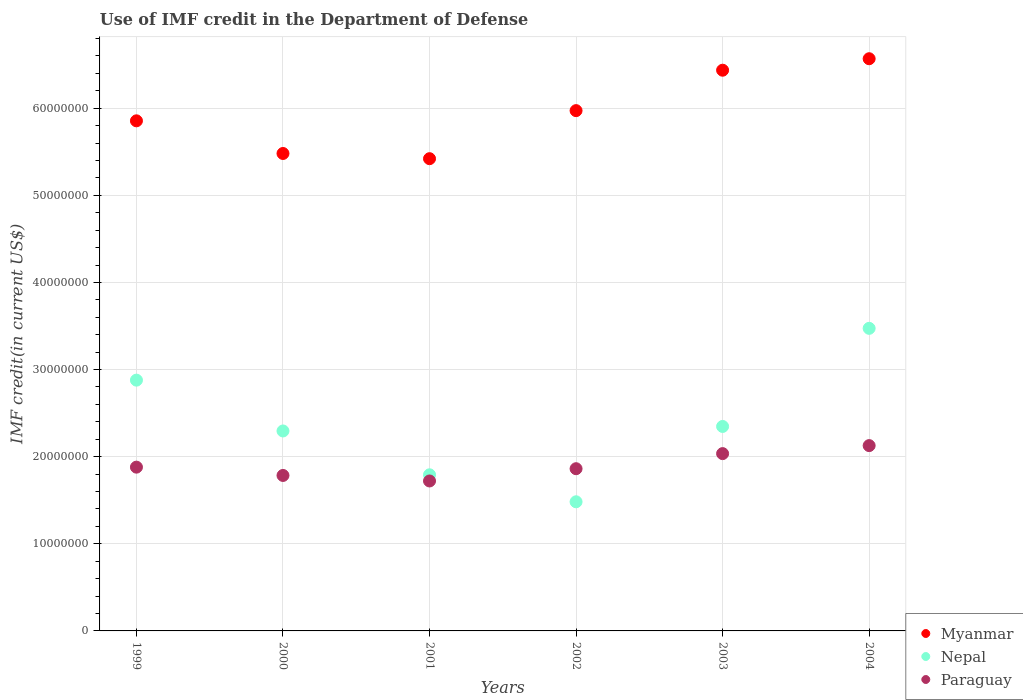How many different coloured dotlines are there?
Your answer should be very brief. 3. What is the IMF credit in the Department of Defense in Paraguay in 2000?
Your answer should be compact. 1.78e+07. Across all years, what is the maximum IMF credit in the Department of Defense in Nepal?
Your answer should be compact. 3.47e+07. Across all years, what is the minimum IMF credit in the Department of Defense in Paraguay?
Your response must be concise. 1.72e+07. In which year was the IMF credit in the Department of Defense in Paraguay maximum?
Provide a succinct answer. 2004. What is the total IMF credit in the Department of Defense in Nepal in the graph?
Your response must be concise. 1.43e+08. What is the difference between the IMF credit in the Department of Defense in Nepal in 2000 and that in 2003?
Your answer should be compact. -5.18e+05. What is the difference between the IMF credit in the Department of Defense in Myanmar in 2002 and the IMF credit in the Department of Defense in Paraguay in 2003?
Give a very brief answer. 3.94e+07. What is the average IMF credit in the Department of Defense in Paraguay per year?
Offer a very short reply. 1.90e+07. In the year 2001, what is the difference between the IMF credit in the Department of Defense in Myanmar and IMF credit in the Department of Defense in Paraguay?
Keep it short and to the point. 3.70e+07. What is the ratio of the IMF credit in the Department of Defense in Paraguay in 1999 to that in 2003?
Your response must be concise. 0.92. Is the IMF credit in the Department of Defense in Nepal in 1999 less than that in 2003?
Make the answer very short. No. What is the difference between the highest and the second highest IMF credit in the Department of Defense in Paraguay?
Provide a succinct answer. 9.19e+05. What is the difference between the highest and the lowest IMF credit in the Department of Defense in Nepal?
Your response must be concise. 1.99e+07. Is the sum of the IMF credit in the Department of Defense in Nepal in 1999 and 2000 greater than the maximum IMF credit in the Department of Defense in Paraguay across all years?
Give a very brief answer. Yes. Does the IMF credit in the Department of Defense in Nepal monotonically increase over the years?
Provide a short and direct response. No. Is the IMF credit in the Department of Defense in Myanmar strictly greater than the IMF credit in the Department of Defense in Nepal over the years?
Your answer should be very brief. Yes. How many years are there in the graph?
Offer a terse response. 6. Are the values on the major ticks of Y-axis written in scientific E-notation?
Your response must be concise. No. Does the graph contain any zero values?
Your answer should be very brief. No. Does the graph contain grids?
Your answer should be compact. Yes. Where does the legend appear in the graph?
Your response must be concise. Bottom right. What is the title of the graph?
Offer a terse response. Use of IMF credit in the Department of Defense. Does "Lithuania" appear as one of the legend labels in the graph?
Give a very brief answer. No. What is the label or title of the X-axis?
Provide a succinct answer. Years. What is the label or title of the Y-axis?
Your answer should be very brief. IMF credit(in current US$). What is the IMF credit(in current US$) in Myanmar in 1999?
Your answer should be compact. 5.86e+07. What is the IMF credit(in current US$) of Nepal in 1999?
Offer a terse response. 2.88e+07. What is the IMF credit(in current US$) of Paraguay in 1999?
Ensure brevity in your answer.  1.88e+07. What is the IMF credit(in current US$) of Myanmar in 2000?
Your response must be concise. 5.48e+07. What is the IMF credit(in current US$) in Nepal in 2000?
Provide a short and direct response. 2.30e+07. What is the IMF credit(in current US$) in Paraguay in 2000?
Offer a very short reply. 1.78e+07. What is the IMF credit(in current US$) in Myanmar in 2001?
Offer a terse response. 5.42e+07. What is the IMF credit(in current US$) in Nepal in 2001?
Your answer should be compact. 1.79e+07. What is the IMF credit(in current US$) of Paraguay in 2001?
Your answer should be very brief. 1.72e+07. What is the IMF credit(in current US$) in Myanmar in 2002?
Offer a terse response. 5.97e+07. What is the IMF credit(in current US$) in Nepal in 2002?
Offer a terse response. 1.48e+07. What is the IMF credit(in current US$) of Paraguay in 2002?
Your answer should be compact. 1.86e+07. What is the IMF credit(in current US$) of Myanmar in 2003?
Make the answer very short. 6.44e+07. What is the IMF credit(in current US$) in Nepal in 2003?
Offer a terse response. 2.35e+07. What is the IMF credit(in current US$) in Paraguay in 2003?
Provide a succinct answer. 2.04e+07. What is the IMF credit(in current US$) in Myanmar in 2004?
Provide a short and direct response. 6.57e+07. What is the IMF credit(in current US$) in Nepal in 2004?
Offer a very short reply. 3.47e+07. What is the IMF credit(in current US$) of Paraguay in 2004?
Your response must be concise. 2.13e+07. Across all years, what is the maximum IMF credit(in current US$) of Myanmar?
Make the answer very short. 6.57e+07. Across all years, what is the maximum IMF credit(in current US$) of Nepal?
Ensure brevity in your answer.  3.47e+07. Across all years, what is the maximum IMF credit(in current US$) of Paraguay?
Your answer should be very brief. 2.13e+07. Across all years, what is the minimum IMF credit(in current US$) of Myanmar?
Offer a very short reply. 5.42e+07. Across all years, what is the minimum IMF credit(in current US$) of Nepal?
Ensure brevity in your answer.  1.48e+07. Across all years, what is the minimum IMF credit(in current US$) in Paraguay?
Offer a terse response. 1.72e+07. What is the total IMF credit(in current US$) of Myanmar in the graph?
Keep it short and to the point. 3.57e+08. What is the total IMF credit(in current US$) of Nepal in the graph?
Your answer should be compact. 1.43e+08. What is the total IMF credit(in current US$) in Paraguay in the graph?
Give a very brief answer. 1.14e+08. What is the difference between the IMF credit(in current US$) in Myanmar in 1999 and that in 2000?
Provide a succinct answer. 3.75e+06. What is the difference between the IMF credit(in current US$) of Nepal in 1999 and that in 2000?
Provide a succinct answer. 5.83e+06. What is the difference between the IMF credit(in current US$) in Paraguay in 1999 and that in 2000?
Your answer should be compact. 9.53e+05. What is the difference between the IMF credit(in current US$) in Myanmar in 1999 and that in 2001?
Offer a terse response. 4.35e+06. What is the difference between the IMF credit(in current US$) in Nepal in 1999 and that in 2001?
Make the answer very short. 1.09e+07. What is the difference between the IMF credit(in current US$) of Paraguay in 1999 and that in 2001?
Offer a very short reply. 1.59e+06. What is the difference between the IMF credit(in current US$) of Myanmar in 1999 and that in 2002?
Ensure brevity in your answer.  -1.17e+06. What is the difference between the IMF credit(in current US$) in Nepal in 1999 and that in 2002?
Make the answer very short. 1.40e+07. What is the difference between the IMF credit(in current US$) in Paraguay in 1999 and that in 2002?
Give a very brief answer. 1.78e+05. What is the difference between the IMF credit(in current US$) of Myanmar in 1999 and that in 2003?
Make the answer very short. -5.81e+06. What is the difference between the IMF credit(in current US$) of Nepal in 1999 and that in 2003?
Your response must be concise. 5.32e+06. What is the difference between the IMF credit(in current US$) in Paraguay in 1999 and that in 2003?
Offer a terse response. -1.55e+06. What is the difference between the IMF credit(in current US$) in Myanmar in 1999 and that in 2004?
Offer a very short reply. -7.13e+06. What is the difference between the IMF credit(in current US$) in Nepal in 1999 and that in 2004?
Make the answer very short. -5.95e+06. What is the difference between the IMF credit(in current US$) of Paraguay in 1999 and that in 2004?
Provide a short and direct response. -2.47e+06. What is the difference between the IMF credit(in current US$) in Myanmar in 2000 and that in 2001?
Provide a succinct answer. 5.97e+05. What is the difference between the IMF credit(in current US$) of Nepal in 2000 and that in 2001?
Give a very brief answer. 5.03e+06. What is the difference between the IMF credit(in current US$) of Paraguay in 2000 and that in 2001?
Ensure brevity in your answer.  6.33e+05. What is the difference between the IMF credit(in current US$) of Myanmar in 2000 and that in 2002?
Offer a terse response. -4.92e+06. What is the difference between the IMF credit(in current US$) in Nepal in 2000 and that in 2002?
Give a very brief answer. 8.13e+06. What is the difference between the IMF credit(in current US$) in Paraguay in 2000 and that in 2002?
Make the answer very short. -7.75e+05. What is the difference between the IMF credit(in current US$) of Myanmar in 2000 and that in 2003?
Ensure brevity in your answer.  -9.56e+06. What is the difference between the IMF credit(in current US$) of Nepal in 2000 and that in 2003?
Offer a very short reply. -5.18e+05. What is the difference between the IMF credit(in current US$) of Paraguay in 2000 and that in 2003?
Make the answer very short. -2.51e+06. What is the difference between the IMF credit(in current US$) of Myanmar in 2000 and that in 2004?
Ensure brevity in your answer.  -1.09e+07. What is the difference between the IMF credit(in current US$) of Nepal in 2000 and that in 2004?
Provide a short and direct response. -1.18e+07. What is the difference between the IMF credit(in current US$) in Paraguay in 2000 and that in 2004?
Your answer should be very brief. -3.43e+06. What is the difference between the IMF credit(in current US$) of Myanmar in 2001 and that in 2002?
Your response must be concise. -5.52e+06. What is the difference between the IMF credit(in current US$) in Nepal in 2001 and that in 2002?
Your answer should be compact. 3.10e+06. What is the difference between the IMF credit(in current US$) in Paraguay in 2001 and that in 2002?
Keep it short and to the point. -1.41e+06. What is the difference between the IMF credit(in current US$) in Myanmar in 2001 and that in 2003?
Your response must be concise. -1.02e+07. What is the difference between the IMF credit(in current US$) in Nepal in 2001 and that in 2003?
Keep it short and to the point. -5.55e+06. What is the difference between the IMF credit(in current US$) in Paraguay in 2001 and that in 2003?
Ensure brevity in your answer.  -3.14e+06. What is the difference between the IMF credit(in current US$) of Myanmar in 2001 and that in 2004?
Make the answer very short. -1.15e+07. What is the difference between the IMF credit(in current US$) of Nepal in 2001 and that in 2004?
Offer a terse response. -1.68e+07. What is the difference between the IMF credit(in current US$) of Paraguay in 2001 and that in 2004?
Offer a very short reply. -4.06e+06. What is the difference between the IMF credit(in current US$) in Myanmar in 2002 and that in 2003?
Make the answer very short. -4.64e+06. What is the difference between the IMF credit(in current US$) in Nepal in 2002 and that in 2003?
Your answer should be compact. -8.65e+06. What is the difference between the IMF credit(in current US$) of Paraguay in 2002 and that in 2003?
Make the answer very short. -1.73e+06. What is the difference between the IMF credit(in current US$) in Myanmar in 2002 and that in 2004?
Provide a succinct answer. -5.96e+06. What is the difference between the IMF credit(in current US$) in Nepal in 2002 and that in 2004?
Keep it short and to the point. -1.99e+07. What is the difference between the IMF credit(in current US$) of Paraguay in 2002 and that in 2004?
Your answer should be very brief. -2.65e+06. What is the difference between the IMF credit(in current US$) in Myanmar in 2003 and that in 2004?
Offer a very short reply. -1.32e+06. What is the difference between the IMF credit(in current US$) of Nepal in 2003 and that in 2004?
Provide a short and direct response. -1.13e+07. What is the difference between the IMF credit(in current US$) in Paraguay in 2003 and that in 2004?
Your response must be concise. -9.19e+05. What is the difference between the IMF credit(in current US$) in Myanmar in 1999 and the IMF credit(in current US$) in Nepal in 2000?
Offer a very short reply. 3.56e+07. What is the difference between the IMF credit(in current US$) in Myanmar in 1999 and the IMF credit(in current US$) in Paraguay in 2000?
Give a very brief answer. 4.07e+07. What is the difference between the IMF credit(in current US$) of Nepal in 1999 and the IMF credit(in current US$) of Paraguay in 2000?
Keep it short and to the point. 1.09e+07. What is the difference between the IMF credit(in current US$) of Myanmar in 1999 and the IMF credit(in current US$) of Nepal in 2001?
Your answer should be very brief. 4.06e+07. What is the difference between the IMF credit(in current US$) of Myanmar in 1999 and the IMF credit(in current US$) of Paraguay in 2001?
Offer a very short reply. 4.13e+07. What is the difference between the IMF credit(in current US$) in Nepal in 1999 and the IMF credit(in current US$) in Paraguay in 2001?
Offer a terse response. 1.16e+07. What is the difference between the IMF credit(in current US$) of Myanmar in 1999 and the IMF credit(in current US$) of Nepal in 2002?
Your response must be concise. 4.37e+07. What is the difference between the IMF credit(in current US$) in Myanmar in 1999 and the IMF credit(in current US$) in Paraguay in 2002?
Your answer should be compact. 3.99e+07. What is the difference between the IMF credit(in current US$) of Nepal in 1999 and the IMF credit(in current US$) of Paraguay in 2002?
Give a very brief answer. 1.02e+07. What is the difference between the IMF credit(in current US$) in Myanmar in 1999 and the IMF credit(in current US$) in Nepal in 2003?
Ensure brevity in your answer.  3.51e+07. What is the difference between the IMF credit(in current US$) in Myanmar in 1999 and the IMF credit(in current US$) in Paraguay in 2003?
Provide a short and direct response. 3.82e+07. What is the difference between the IMF credit(in current US$) in Nepal in 1999 and the IMF credit(in current US$) in Paraguay in 2003?
Make the answer very short. 8.43e+06. What is the difference between the IMF credit(in current US$) in Myanmar in 1999 and the IMF credit(in current US$) in Nepal in 2004?
Provide a succinct answer. 2.38e+07. What is the difference between the IMF credit(in current US$) in Myanmar in 1999 and the IMF credit(in current US$) in Paraguay in 2004?
Provide a succinct answer. 3.73e+07. What is the difference between the IMF credit(in current US$) in Nepal in 1999 and the IMF credit(in current US$) in Paraguay in 2004?
Your answer should be very brief. 7.52e+06. What is the difference between the IMF credit(in current US$) in Myanmar in 2000 and the IMF credit(in current US$) in Nepal in 2001?
Your answer should be compact. 3.69e+07. What is the difference between the IMF credit(in current US$) of Myanmar in 2000 and the IMF credit(in current US$) of Paraguay in 2001?
Your answer should be compact. 3.76e+07. What is the difference between the IMF credit(in current US$) of Nepal in 2000 and the IMF credit(in current US$) of Paraguay in 2001?
Offer a very short reply. 5.74e+06. What is the difference between the IMF credit(in current US$) of Myanmar in 2000 and the IMF credit(in current US$) of Nepal in 2002?
Your answer should be very brief. 4.00e+07. What is the difference between the IMF credit(in current US$) in Myanmar in 2000 and the IMF credit(in current US$) in Paraguay in 2002?
Offer a terse response. 3.62e+07. What is the difference between the IMF credit(in current US$) of Nepal in 2000 and the IMF credit(in current US$) of Paraguay in 2002?
Keep it short and to the point. 4.33e+06. What is the difference between the IMF credit(in current US$) in Myanmar in 2000 and the IMF credit(in current US$) in Nepal in 2003?
Provide a short and direct response. 3.13e+07. What is the difference between the IMF credit(in current US$) of Myanmar in 2000 and the IMF credit(in current US$) of Paraguay in 2003?
Your answer should be very brief. 3.45e+07. What is the difference between the IMF credit(in current US$) in Nepal in 2000 and the IMF credit(in current US$) in Paraguay in 2003?
Make the answer very short. 2.60e+06. What is the difference between the IMF credit(in current US$) of Myanmar in 2000 and the IMF credit(in current US$) of Nepal in 2004?
Offer a very short reply. 2.01e+07. What is the difference between the IMF credit(in current US$) of Myanmar in 2000 and the IMF credit(in current US$) of Paraguay in 2004?
Your answer should be compact. 3.35e+07. What is the difference between the IMF credit(in current US$) of Nepal in 2000 and the IMF credit(in current US$) of Paraguay in 2004?
Your answer should be compact. 1.68e+06. What is the difference between the IMF credit(in current US$) in Myanmar in 2001 and the IMF credit(in current US$) in Nepal in 2002?
Provide a succinct answer. 3.94e+07. What is the difference between the IMF credit(in current US$) in Myanmar in 2001 and the IMF credit(in current US$) in Paraguay in 2002?
Your response must be concise. 3.56e+07. What is the difference between the IMF credit(in current US$) of Nepal in 2001 and the IMF credit(in current US$) of Paraguay in 2002?
Keep it short and to the point. -7.00e+05. What is the difference between the IMF credit(in current US$) of Myanmar in 2001 and the IMF credit(in current US$) of Nepal in 2003?
Provide a succinct answer. 3.07e+07. What is the difference between the IMF credit(in current US$) in Myanmar in 2001 and the IMF credit(in current US$) in Paraguay in 2003?
Ensure brevity in your answer.  3.39e+07. What is the difference between the IMF credit(in current US$) in Nepal in 2001 and the IMF credit(in current US$) in Paraguay in 2003?
Ensure brevity in your answer.  -2.43e+06. What is the difference between the IMF credit(in current US$) of Myanmar in 2001 and the IMF credit(in current US$) of Nepal in 2004?
Provide a succinct answer. 1.95e+07. What is the difference between the IMF credit(in current US$) of Myanmar in 2001 and the IMF credit(in current US$) of Paraguay in 2004?
Your response must be concise. 3.29e+07. What is the difference between the IMF credit(in current US$) of Nepal in 2001 and the IMF credit(in current US$) of Paraguay in 2004?
Make the answer very short. -3.35e+06. What is the difference between the IMF credit(in current US$) of Myanmar in 2002 and the IMF credit(in current US$) of Nepal in 2003?
Your response must be concise. 3.63e+07. What is the difference between the IMF credit(in current US$) of Myanmar in 2002 and the IMF credit(in current US$) of Paraguay in 2003?
Offer a terse response. 3.94e+07. What is the difference between the IMF credit(in current US$) of Nepal in 2002 and the IMF credit(in current US$) of Paraguay in 2003?
Your answer should be very brief. -5.53e+06. What is the difference between the IMF credit(in current US$) in Myanmar in 2002 and the IMF credit(in current US$) in Nepal in 2004?
Make the answer very short. 2.50e+07. What is the difference between the IMF credit(in current US$) of Myanmar in 2002 and the IMF credit(in current US$) of Paraguay in 2004?
Offer a very short reply. 3.85e+07. What is the difference between the IMF credit(in current US$) in Nepal in 2002 and the IMF credit(in current US$) in Paraguay in 2004?
Provide a short and direct response. -6.45e+06. What is the difference between the IMF credit(in current US$) of Myanmar in 2003 and the IMF credit(in current US$) of Nepal in 2004?
Offer a terse response. 2.96e+07. What is the difference between the IMF credit(in current US$) of Myanmar in 2003 and the IMF credit(in current US$) of Paraguay in 2004?
Your answer should be compact. 4.31e+07. What is the difference between the IMF credit(in current US$) of Nepal in 2003 and the IMF credit(in current US$) of Paraguay in 2004?
Make the answer very short. 2.20e+06. What is the average IMF credit(in current US$) of Myanmar per year?
Your answer should be compact. 5.96e+07. What is the average IMF credit(in current US$) in Nepal per year?
Make the answer very short. 2.38e+07. What is the average IMF credit(in current US$) of Paraguay per year?
Your answer should be very brief. 1.90e+07. In the year 1999, what is the difference between the IMF credit(in current US$) of Myanmar and IMF credit(in current US$) of Nepal?
Make the answer very short. 2.98e+07. In the year 1999, what is the difference between the IMF credit(in current US$) of Myanmar and IMF credit(in current US$) of Paraguay?
Your answer should be very brief. 3.98e+07. In the year 1999, what is the difference between the IMF credit(in current US$) in Nepal and IMF credit(in current US$) in Paraguay?
Make the answer very short. 9.99e+06. In the year 2000, what is the difference between the IMF credit(in current US$) of Myanmar and IMF credit(in current US$) of Nepal?
Offer a very short reply. 3.19e+07. In the year 2000, what is the difference between the IMF credit(in current US$) of Myanmar and IMF credit(in current US$) of Paraguay?
Provide a succinct answer. 3.70e+07. In the year 2000, what is the difference between the IMF credit(in current US$) of Nepal and IMF credit(in current US$) of Paraguay?
Your response must be concise. 5.11e+06. In the year 2001, what is the difference between the IMF credit(in current US$) of Myanmar and IMF credit(in current US$) of Nepal?
Provide a succinct answer. 3.63e+07. In the year 2001, what is the difference between the IMF credit(in current US$) in Myanmar and IMF credit(in current US$) in Paraguay?
Offer a very short reply. 3.70e+07. In the year 2001, what is the difference between the IMF credit(in current US$) of Nepal and IMF credit(in current US$) of Paraguay?
Ensure brevity in your answer.  7.08e+05. In the year 2002, what is the difference between the IMF credit(in current US$) of Myanmar and IMF credit(in current US$) of Nepal?
Provide a succinct answer. 4.49e+07. In the year 2002, what is the difference between the IMF credit(in current US$) in Myanmar and IMF credit(in current US$) in Paraguay?
Offer a terse response. 4.11e+07. In the year 2002, what is the difference between the IMF credit(in current US$) in Nepal and IMF credit(in current US$) in Paraguay?
Give a very brief answer. -3.80e+06. In the year 2003, what is the difference between the IMF credit(in current US$) of Myanmar and IMF credit(in current US$) of Nepal?
Ensure brevity in your answer.  4.09e+07. In the year 2003, what is the difference between the IMF credit(in current US$) in Myanmar and IMF credit(in current US$) in Paraguay?
Ensure brevity in your answer.  4.40e+07. In the year 2003, what is the difference between the IMF credit(in current US$) in Nepal and IMF credit(in current US$) in Paraguay?
Give a very brief answer. 3.12e+06. In the year 2004, what is the difference between the IMF credit(in current US$) of Myanmar and IMF credit(in current US$) of Nepal?
Your answer should be very brief. 3.09e+07. In the year 2004, what is the difference between the IMF credit(in current US$) of Myanmar and IMF credit(in current US$) of Paraguay?
Your response must be concise. 4.44e+07. In the year 2004, what is the difference between the IMF credit(in current US$) in Nepal and IMF credit(in current US$) in Paraguay?
Make the answer very short. 1.35e+07. What is the ratio of the IMF credit(in current US$) of Myanmar in 1999 to that in 2000?
Ensure brevity in your answer.  1.07. What is the ratio of the IMF credit(in current US$) of Nepal in 1999 to that in 2000?
Your answer should be very brief. 1.25. What is the ratio of the IMF credit(in current US$) in Paraguay in 1999 to that in 2000?
Your response must be concise. 1.05. What is the ratio of the IMF credit(in current US$) of Myanmar in 1999 to that in 2001?
Provide a succinct answer. 1.08. What is the ratio of the IMF credit(in current US$) in Nepal in 1999 to that in 2001?
Your answer should be compact. 1.61. What is the ratio of the IMF credit(in current US$) of Paraguay in 1999 to that in 2001?
Provide a short and direct response. 1.09. What is the ratio of the IMF credit(in current US$) of Myanmar in 1999 to that in 2002?
Make the answer very short. 0.98. What is the ratio of the IMF credit(in current US$) in Nepal in 1999 to that in 2002?
Your answer should be compact. 1.94. What is the ratio of the IMF credit(in current US$) in Paraguay in 1999 to that in 2002?
Give a very brief answer. 1.01. What is the ratio of the IMF credit(in current US$) in Myanmar in 1999 to that in 2003?
Offer a terse response. 0.91. What is the ratio of the IMF credit(in current US$) of Nepal in 1999 to that in 2003?
Your answer should be compact. 1.23. What is the ratio of the IMF credit(in current US$) in Paraguay in 1999 to that in 2003?
Ensure brevity in your answer.  0.92. What is the ratio of the IMF credit(in current US$) of Myanmar in 1999 to that in 2004?
Your answer should be very brief. 0.89. What is the ratio of the IMF credit(in current US$) in Nepal in 1999 to that in 2004?
Give a very brief answer. 0.83. What is the ratio of the IMF credit(in current US$) in Paraguay in 1999 to that in 2004?
Your response must be concise. 0.88. What is the ratio of the IMF credit(in current US$) in Nepal in 2000 to that in 2001?
Provide a succinct answer. 1.28. What is the ratio of the IMF credit(in current US$) in Paraguay in 2000 to that in 2001?
Your answer should be very brief. 1.04. What is the ratio of the IMF credit(in current US$) in Myanmar in 2000 to that in 2002?
Offer a very short reply. 0.92. What is the ratio of the IMF credit(in current US$) in Nepal in 2000 to that in 2002?
Provide a succinct answer. 1.55. What is the ratio of the IMF credit(in current US$) in Paraguay in 2000 to that in 2002?
Keep it short and to the point. 0.96. What is the ratio of the IMF credit(in current US$) of Myanmar in 2000 to that in 2003?
Offer a very short reply. 0.85. What is the ratio of the IMF credit(in current US$) of Nepal in 2000 to that in 2003?
Ensure brevity in your answer.  0.98. What is the ratio of the IMF credit(in current US$) in Paraguay in 2000 to that in 2003?
Ensure brevity in your answer.  0.88. What is the ratio of the IMF credit(in current US$) in Myanmar in 2000 to that in 2004?
Provide a succinct answer. 0.83. What is the ratio of the IMF credit(in current US$) of Nepal in 2000 to that in 2004?
Provide a succinct answer. 0.66. What is the ratio of the IMF credit(in current US$) of Paraguay in 2000 to that in 2004?
Your answer should be very brief. 0.84. What is the ratio of the IMF credit(in current US$) of Myanmar in 2001 to that in 2002?
Your response must be concise. 0.91. What is the ratio of the IMF credit(in current US$) of Nepal in 2001 to that in 2002?
Offer a terse response. 1.21. What is the ratio of the IMF credit(in current US$) in Paraguay in 2001 to that in 2002?
Offer a terse response. 0.92. What is the ratio of the IMF credit(in current US$) of Myanmar in 2001 to that in 2003?
Provide a short and direct response. 0.84. What is the ratio of the IMF credit(in current US$) in Nepal in 2001 to that in 2003?
Offer a very short reply. 0.76. What is the ratio of the IMF credit(in current US$) in Paraguay in 2001 to that in 2003?
Make the answer very short. 0.85. What is the ratio of the IMF credit(in current US$) of Myanmar in 2001 to that in 2004?
Keep it short and to the point. 0.83. What is the ratio of the IMF credit(in current US$) of Nepal in 2001 to that in 2004?
Offer a very short reply. 0.52. What is the ratio of the IMF credit(in current US$) of Paraguay in 2001 to that in 2004?
Your answer should be very brief. 0.81. What is the ratio of the IMF credit(in current US$) in Myanmar in 2002 to that in 2003?
Make the answer very short. 0.93. What is the ratio of the IMF credit(in current US$) of Nepal in 2002 to that in 2003?
Offer a terse response. 0.63. What is the ratio of the IMF credit(in current US$) in Paraguay in 2002 to that in 2003?
Your answer should be very brief. 0.91. What is the ratio of the IMF credit(in current US$) of Myanmar in 2002 to that in 2004?
Provide a succinct answer. 0.91. What is the ratio of the IMF credit(in current US$) of Nepal in 2002 to that in 2004?
Ensure brevity in your answer.  0.43. What is the ratio of the IMF credit(in current US$) of Paraguay in 2002 to that in 2004?
Make the answer very short. 0.88. What is the ratio of the IMF credit(in current US$) of Myanmar in 2003 to that in 2004?
Your response must be concise. 0.98. What is the ratio of the IMF credit(in current US$) of Nepal in 2003 to that in 2004?
Provide a short and direct response. 0.68. What is the ratio of the IMF credit(in current US$) of Paraguay in 2003 to that in 2004?
Your answer should be compact. 0.96. What is the difference between the highest and the second highest IMF credit(in current US$) of Myanmar?
Offer a very short reply. 1.32e+06. What is the difference between the highest and the second highest IMF credit(in current US$) of Nepal?
Give a very brief answer. 5.95e+06. What is the difference between the highest and the second highest IMF credit(in current US$) of Paraguay?
Provide a short and direct response. 9.19e+05. What is the difference between the highest and the lowest IMF credit(in current US$) of Myanmar?
Offer a terse response. 1.15e+07. What is the difference between the highest and the lowest IMF credit(in current US$) of Nepal?
Give a very brief answer. 1.99e+07. What is the difference between the highest and the lowest IMF credit(in current US$) of Paraguay?
Make the answer very short. 4.06e+06. 